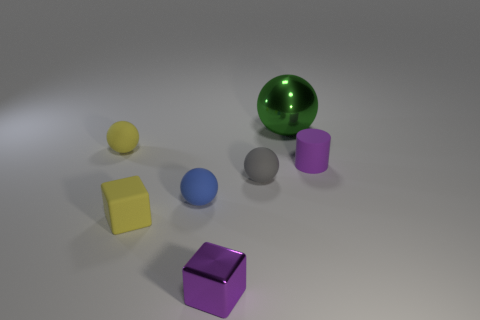There is a metallic object that is in front of the big shiny object; is its color the same as the rubber sphere to the left of the small yellow block?
Ensure brevity in your answer.  No. Are there any yellow spheres made of the same material as the blue object?
Provide a short and direct response. Yes. What number of red things are small rubber cylinders or large metallic spheres?
Make the answer very short. 0. Is the number of small matte cubes that are to the right of the big sphere greater than the number of gray objects?
Provide a short and direct response. No. Do the blue sphere and the metallic cube have the same size?
Offer a terse response. Yes. What is the color of the object that is made of the same material as the green sphere?
Your answer should be very brief. Purple. What is the shape of the rubber object that is the same color as the rubber block?
Give a very brief answer. Sphere. Is the number of cylinders in front of the tiny shiny block the same as the number of small matte balls that are on the right side of the tiny yellow cube?
Make the answer very short. No. There is a small yellow matte thing in front of the small thing to the left of the tiny yellow rubber cube; what shape is it?
Provide a short and direct response. Cube. There is a small yellow thing that is the same shape as the gray thing; what material is it?
Keep it short and to the point. Rubber. 